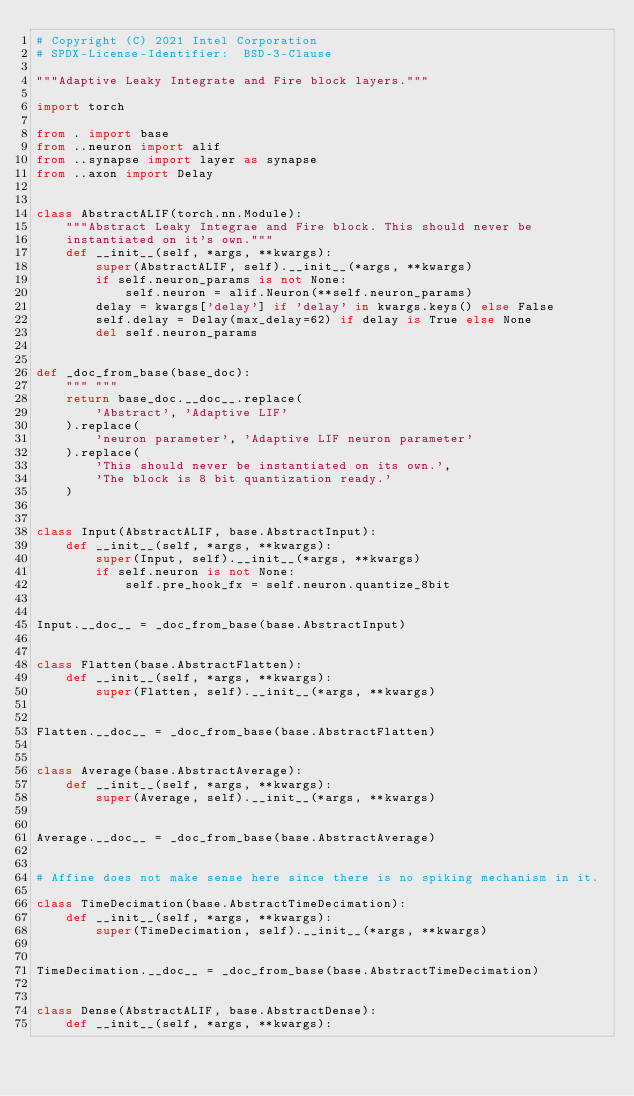<code> <loc_0><loc_0><loc_500><loc_500><_Python_># Copyright (C) 2021 Intel Corporation
# SPDX-License-Identifier:  BSD-3-Clause

"""Adaptive Leaky Integrate and Fire block layers."""

import torch

from . import base
from ..neuron import alif
from ..synapse import layer as synapse
from ..axon import Delay


class AbstractALIF(torch.nn.Module):
    """Abstract Leaky Integrae and Fire block. This should never be
    instantiated on it's own."""
    def __init__(self, *args, **kwargs):
        super(AbstractALIF, self).__init__(*args, **kwargs)
        if self.neuron_params is not None:
            self.neuron = alif.Neuron(**self.neuron_params)
        delay = kwargs['delay'] if 'delay' in kwargs.keys() else False
        self.delay = Delay(max_delay=62) if delay is True else None
        del self.neuron_params


def _doc_from_base(base_doc):
    """ """
    return base_doc.__doc__.replace(
        'Abstract', 'Adaptive LIF'
    ).replace(
        'neuron parameter', 'Adaptive LIF neuron parameter'
    ).replace(
        'This should never be instantiated on its own.',
        'The block is 8 bit quantization ready.'
    )


class Input(AbstractALIF, base.AbstractInput):
    def __init__(self, *args, **kwargs):
        super(Input, self).__init__(*args, **kwargs)
        if self.neuron is not None:
            self.pre_hook_fx = self.neuron.quantize_8bit


Input.__doc__ = _doc_from_base(base.AbstractInput)


class Flatten(base.AbstractFlatten):
    def __init__(self, *args, **kwargs):
        super(Flatten, self).__init__(*args, **kwargs)


Flatten.__doc__ = _doc_from_base(base.AbstractFlatten)


class Average(base.AbstractAverage):
    def __init__(self, *args, **kwargs):
        super(Average, self).__init__(*args, **kwargs)


Average.__doc__ = _doc_from_base(base.AbstractAverage)


# Affine does not make sense here since there is no spiking mechanism in it.

class TimeDecimation(base.AbstractTimeDecimation):
    def __init__(self, *args, **kwargs):
        super(TimeDecimation, self).__init__(*args, **kwargs)


TimeDecimation.__doc__ = _doc_from_base(base.AbstractTimeDecimation)


class Dense(AbstractALIF, base.AbstractDense):
    def __init__(self, *args, **kwargs):</code> 